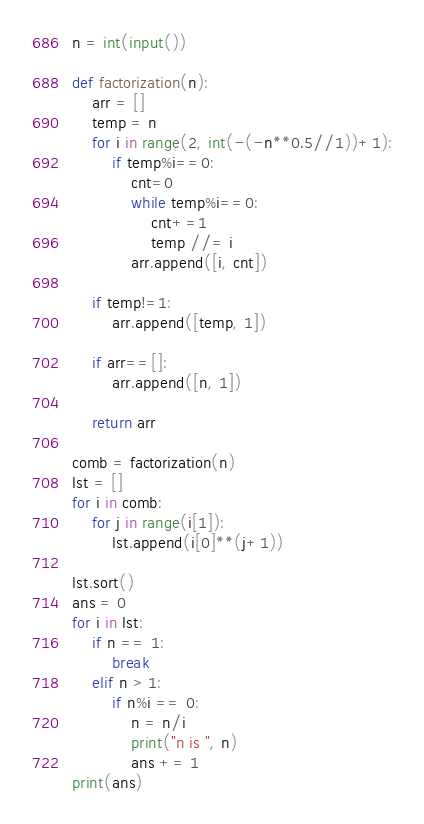Convert code to text. <code><loc_0><loc_0><loc_500><loc_500><_Python_>n = int(input())

def factorization(n):
    arr = []
    temp = n
    for i in range(2, int(-(-n**0.5//1))+1):
        if temp%i==0:
            cnt=0
            while temp%i==0:
                cnt+=1
                temp //= i
            arr.append([i, cnt])

    if temp!=1:
        arr.append([temp, 1])

    if arr==[]:
        arr.append([n, 1])

    return arr

comb = factorization(n)
lst = []
for i in comb:
    for j in range(i[1]):
        lst.append(i[0]**(j+1))

lst.sort()
ans = 0
for i in lst:
    if n == 1:
        break
    elif n > 1:
        if n%i == 0:
            n = n/i
            print("n is ", n)
            ans += 1
print(ans)
</code> 